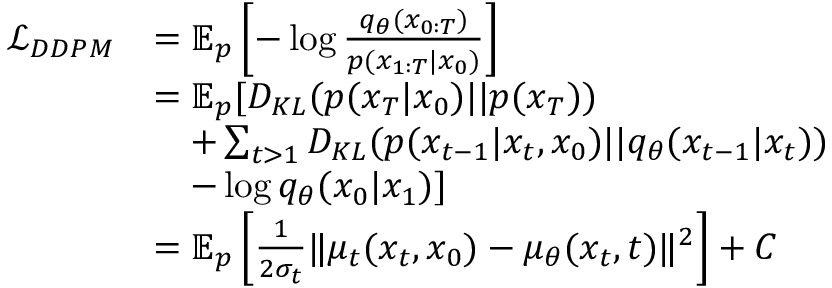<formula> <loc_0><loc_0><loc_500><loc_500>\begin{array} { r l } { \mathcal { L } _ { D D P M } } & { = \mathbb { E } _ { p } \left [ - \log \frac { q _ { \theta } ( x _ { 0 \colon T } ) } { p ( x _ { 1 \colon T } | x _ { 0 } ) } \right ] } \\ & { = \mathbb { E } _ { p } [ D _ { K L } ( p ( x _ { T } | x _ { 0 } ) | | p ( x _ { T } ) ) } \\ & { \quad + \sum _ { t > 1 } D _ { K L } ( p ( x _ { t - 1 } | x _ { t } , x _ { 0 } ) | | q _ { \theta } ( x _ { t - 1 } | x _ { t } ) ) } \\ & { \quad - \log q _ { \theta } ( x _ { 0 } | x _ { 1 } ) ] } \\ & { = \mathbb { E } _ { p } \left [ \frac { 1 } { 2 \sigma _ { t } } \| \mu _ { t } ( x _ { t } , x _ { 0 } ) - \mu _ { \theta } ( x _ { t } , t ) \| ^ { 2 } \right ] + C } \end{array}</formula> 